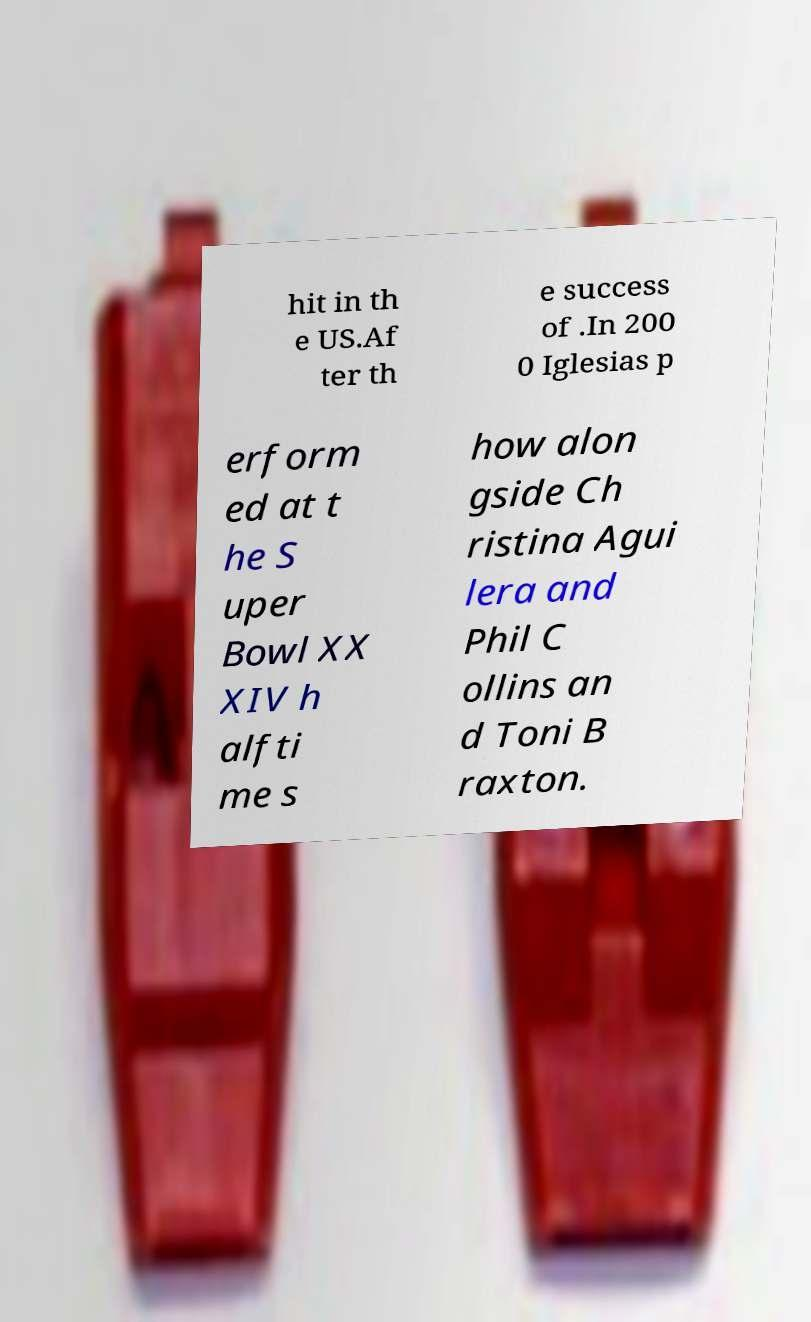Could you assist in decoding the text presented in this image and type it out clearly? hit in th e US.Af ter th e success of .In 200 0 Iglesias p erform ed at t he S uper Bowl XX XIV h alfti me s how alon gside Ch ristina Agui lera and Phil C ollins an d Toni B raxton. 